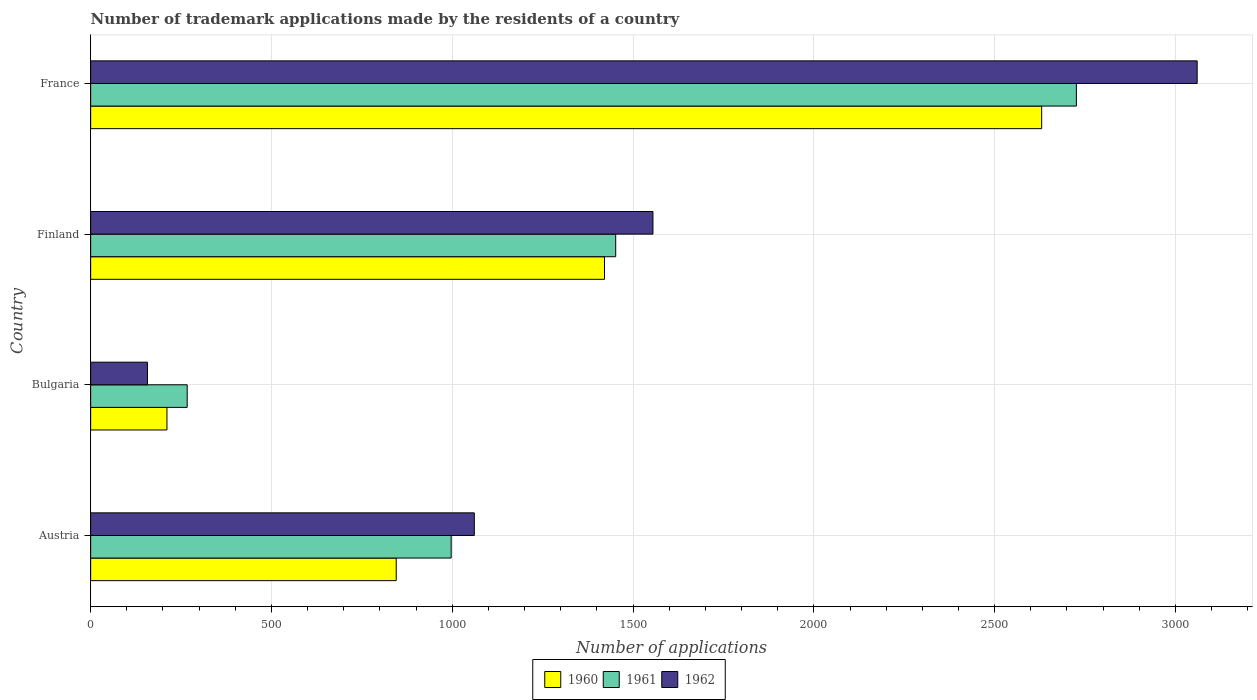How many different coloured bars are there?
Provide a short and direct response. 3. Are the number of bars per tick equal to the number of legend labels?
Your answer should be very brief. Yes. Are the number of bars on each tick of the Y-axis equal?
Give a very brief answer. Yes. How many bars are there on the 1st tick from the top?
Offer a terse response. 3. What is the label of the 4th group of bars from the top?
Your response must be concise. Austria. What is the number of trademark applications made by the residents in 1962 in Austria?
Offer a very short reply. 1061. Across all countries, what is the maximum number of trademark applications made by the residents in 1962?
Provide a short and direct response. 3060. Across all countries, what is the minimum number of trademark applications made by the residents in 1960?
Your response must be concise. 211. In which country was the number of trademark applications made by the residents in 1960 maximum?
Make the answer very short. France. In which country was the number of trademark applications made by the residents in 1960 minimum?
Offer a very short reply. Bulgaria. What is the total number of trademark applications made by the residents in 1961 in the graph?
Offer a terse response. 5442. What is the difference between the number of trademark applications made by the residents in 1960 in Finland and that in France?
Make the answer very short. -1209. What is the difference between the number of trademark applications made by the residents in 1961 in Bulgaria and the number of trademark applications made by the residents in 1962 in France?
Your answer should be very brief. -2793. What is the average number of trademark applications made by the residents in 1961 per country?
Offer a very short reply. 1360.5. What is the difference between the number of trademark applications made by the residents in 1960 and number of trademark applications made by the residents in 1961 in Bulgaria?
Make the answer very short. -56. What is the ratio of the number of trademark applications made by the residents in 1961 in Austria to that in Bulgaria?
Offer a terse response. 3.73. Is the number of trademark applications made by the residents in 1961 in Austria less than that in Bulgaria?
Offer a very short reply. No. What is the difference between the highest and the second highest number of trademark applications made by the residents in 1962?
Give a very brief answer. 1505. What is the difference between the highest and the lowest number of trademark applications made by the residents in 1960?
Your response must be concise. 2419. In how many countries, is the number of trademark applications made by the residents in 1961 greater than the average number of trademark applications made by the residents in 1961 taken over all countries?
Your answer should be compact. 2. Is it the case that in every country, the sum of the number of trademark applications made by the residents in 1962 and number of trademark applications made by the residents in 1961 is greater than the number of trademark applications made by the residents in 1960?
Offer a terse response. Yes. Are all the bars in the graph horizontal?
Provide a succinct answer. Yes. How many countries are there in the graph?
Keep it short and to the point. 4. What is the difference between two consecutive major ticks on the X-axis?
Make the answer very short. 500. Does the graph contain any zero values?
Ensure brevity in your answer.  No. How many legend labels are there?
Make the answer very short. 3. What is the title of the graph?
Give a very brief answer. Number of trademark applications made by the residents of a country. What is the label or title of the X-axis?
Your answer should be compact. Number of applications. What is the label or title of the Y-axis?
Provide a short and direct response. Country. What is the Number of applications of 1960 in Austria?
Your response must be concise. 845. What is the Number of applications of 1961 in Austria?
Give a very brief answer. 997. What is the Number of applications of 1962 in Austria?
Keep it short and to the point. 1061. What is the Number of applications of 1960 in Bulgaria?
Offer a terse response. 211. What is the Number of applications of 1961 in Bulgaria?
Your response must be concise. 267. What is the Number of applications in 1962 in Bulgaria?
Your answer should be compact. 157. What is the Number of applications of 1960 in Finland?
Offer a very short reply. 1421. What is the Number of applications in 1961 in Finland?
Provide a succinct answer. 1452. What is the Number of applications of 1962 in Finland?
Ensure brevity in your answer.  1555. What is the Number of applications in 1960 in France?
Provide a short and direct response. 2630. What is the Number of applications in 1961 in France?
Your response must be concise. 2726. What is the Number of applications in 1962 in France?
Give a very brief answer. 3060. Across all countries, what is the maximum Number of applications in 1960?
Ensure brevity in your answer.  2630. Across all countries, what is the maximum Number of applications in 1961?
Your answer should be very brief. 2726. Across all countries, what is the maximum Number of applications in 1962?
Offer a terse response. 3060. Across all countries, what is the minimum Number of applications in 1960?
Offer a very short reply. 211. Across all countries, what is the minimum Number of applications of 1961?
Your answer should be compact. 267. Across all countries, what is the minimum Number of applications in 1962?
Keep it short and to the point. 157. What is the total Number of applications of 1960 in the graph?
Provide a succinct answer. 5107. What is the total Number of applications in 1961 in the graph?
Your response must be concise. 5442. What is the total Number of applications in 1962 in the graph?
Provide a succinct answer. 5833. What is the difference between the Number of applications in 1960 in Austria and that in Bulgaria?
Offer a very short reply. 634. What is the difference between the Number of applications in 1961 in Austria and that in Bulgaria?
Offer a very short reply. 730. What is the difference between the Number of applications of 1962 in Austria and that in Bulgaria?
Give a very brief answer. 904. What is the difference between the Number of applications in 1960 in Austria and that in Finland?
Provide a short and direct response. -576. What is the difference between the Number of applications in 1961 in Austria and that in Finland?
Your answer should be compact. -455. What is the difference between the Number of applications in 1962 in Austria and that in Finland?
Give a very brief answer. -494. What is the difference between the Number of applications of 1960 in Austria and that in France?
Provide a succinct answer. -1785. What is the difference between the Number of applications in 1961 in Austria and that in France?
Your answer should be very brief. -1729. What is the difference between the Number of applications in 1962 in Austria and that in France?
Your response must be concise. -1999. What is the difference between the Number of applications in 1960 in Bulgaria and that in Finland?
Make the answer very short. -1210. What is the difference between the Number of applications in 1961 in Bulgaria and that in Finland?
Your answer should be very brief. -1185. What is the difference between the Number of applications of 1962 in Bulgaria and that in Finland?
Keep it short and to the point. -1398. What is the difference between the Number of applications of 1960 in Bulgaria and that in France?
Your answer should be compact. -2419. What is the difference between the Number of applications in 1961 in Bulgaria and that in France?
Provide a short and direct response. -2459. What is the difference between the Number of applications in 1962 in Bulgaria and that in France?
Make the answer very short. -2903. What is the difference between the Number of applications in 1960 in Finland and that in France?
Your answer should be very brief. -1209. What is the difference between the Number of applications of 1961 in Finland and that in France?
Your answer should be very brief. -1274. What is the difference between the Number of applications of 1962 in Finland and that in France?
Provide a short and direct response. -1505. What is the difference between the Number of applications of 1960 in Austria and the Number of applications of 1961 in Bulgaria?
Your answer should be very brief. 578. What is the difference between the Number of applications in 1960 in Austria and the Number of applications in 1962 in Bulgaria?
Provide a short and direct response. 688. What is the difference between the Number of applications of 1961 in Austria and the Number of applications of 1962 in Bulgaria?
Your answer should be very brief. 840. What is the difference between the Number of applications of 1960 in Austria and the Number of applications of 1961 in Finland?
Offer a very short reply. -607. What is the difference between the Number of applications of 1960 in Austria and the Number of applications of 1962 in Finland?
Your response must be concise. -710. What is the difference between the Number of applications of 1961 in Austria and the Number of applications of 1962 in Finland?
Your answer should be very brief. -558. What is the difference between the Number of applications in 1960 in Austria and the Number of applications in 1961 in France?
Provide a succinct answer. -1881. What is the difference between the Number of applications in 1960 in Austria and the Number of applications in 1962 in France?
Provide a short and direct response. -2215. What is the difference between the Number of applications in 1961 in Austria and the Number of applications in 1962 in France?
Offer a very short reply. -2063. What is the difference between the Number of applications of 1960 in Bulgaria and the Number of applications of 1961 in Finland?
Ensure brevity in your answer.  -1241. What is the difference between the Number of applications in 1960 in Bulgaria and the Number of applications in 1962 in Finland?
Offer a very short reply. -1344. What is the difference between the Number of applications in 1961 in Bulgaria and the Number of applications in 1962 in Finland?
Provide a succinct answer. -1288. What is the difference between the Number of applications in 1960 in Bulgaria and the Number of applications in 1961 in France?
Offer a very short reply. -2515. What is the difference between the Number of applications of 1960 in Bulgaria and the Number of applications of 1962 in France?
Give a very brief answer. -2849. What is the difference between the Number of applications in 1961 in Bulgaria and the Number of applications in 1962 in France?
Keep it short and to the point. -2793. What is the difference between the Number of applications of 1960 in Finland and the Number of applications of 1961 in France?
Offer a terse response. -1305. What is the difference between the Number of applications of 1960 in Finland and the Number of applications of 1962 in France?
Your answer should be very brief. -1639. What is the difference between the Number of applications in 1961 in Finland and the Number of applications in 1962 in France?
Your answer should be very brief. -1608. What is the average Number of applications of 1960 per country?
Provide a succinct answer. 1276.75. What is the average Number of applications in 1961 per country?
Give a very brief answer. 1360.5. What is the average Number of applications in 1962 per country?
Keep it short and to the point. 1458.25. What is the difference between the Number of applications in 1960 and Number of applications in 1961 in Austria?
Provide a short and direct response. -152. What is the difference between the Number of applications in 1960 and Number of applications in 1962 in Austria?
Make the answer very short. -216. What is the difference between the Number of applications in 1961 and Number of applications in 1962 in Austria?
Ensure brevity in your answer.  -64. What is the difference between the Number of applications of 1960 and Number of applications of 1961 in Bulgaria?
Ensure brevity in your answer.  -56. What is the difference between the Number of applications of 1961 and Number of applications of 1962 in Bulgaria?
Make the answer very short. 110. What is the difference between the Number of applications of 1960 and Number of applications of 1961 in Finland?
Give a very brief answer. -31. What is the difference between the Number of applications in 1960 and Number of applications in 1962 in Finland?
Make the answer very short. -134. What is the difference between the Number of applications of 1961 and Number of applications of 1962 in Finland?
Your answer should be compact. -103. What is the difference between the Number of applications of 1960 and Number of applications of 1961 in France?
Offer a very short reply. -96. What is the difference between the Number of applications of 1960 and Number of applications of 1962 in France?
Your answer should be compact. -430. What is the difference between the Number of applications in 1961 and Number of applications in 1962 in France?
Your answer should be very brief. -334. What is the ratio of the Number of applications of 1960 in Austria to that in Bulgaria?
Your answer should be compact. 4. What is the ratio of the Number of applications in 1961 in Austria to that in Bulgaria?
Provide a succinct answer. 3.73. What is the ratio of the Number of applications in 1962 in Austria to that in Bulgaria?
Your answer should be compact. 6.76. What is the ratio of the Number of applications of 1960 in Austria to that in Finland?
Offer a terse response. 0.59. What is the ratio of the Number of applications of 1961 in Austria to that in Finland?
Make the answer very short. 0.69. What is the ratio of the Number of applications in 1962 in Austria to that in Finland?
Give a very brief answer. 0.68. What is the ratio of the Number of applications of 1960 in Austria to that in France?
Provide a succinct answer. 0.32. What is the ratio of the Number of applications in 1961 in Austria to that in France?
Make the answer very short. 0.37. What is the ratio of the Number of applications of 1962 in Austria to that in France?
Your answer should be very brief. 0.35. What is the ratio of the Number of applications of 1960 in Bulgaria to that in Finland?
Offer a terse response. 0.15. What is the ratio of the Number of applications in 1961 in Bulgaria to that in Finland?
Keep it short and to the point. 0.18. What is the ratio of the Number of applications of 1962 in Bulgaria to that in Finland?
Offer a very short reply. 0.1. What is the ratio of the Number of applications in 1960 in Bulgaria to that in France?
Offer a terse response. 0.08. What is the ratio of the Number of applications in 1961 in Bulgaria to that in France?
Provide a succinct answer. 0.1. What is the ratio of the Number of applications of 1962 in Bulgaria to that in France?
Give a very brief answer. 0.05. What is the ratio of the Number of applications in 1960 in Finland to that in France?
Offer a very short reply. 0.54. What is the ratio of the Number of applications in 1961 in Finland to that in France?
Provide a succinct answer. 0.53. What is the ratio of the Number of applications of 1962 in Finland to that in France?
Provide a succinct answer. 0.51. What is the difference between the highest and the second highest Number of applications in 1960?
Give a very brief answer. 1209. What is the difference between the highest and the second highest Number of applications of 1961?
Your answer should be compact. 1274. What is the difference between the highest and the second highest Number of applications of 1962?
Offer a very short reply. 1505. What is the difference between the highest and the lowest Number of applications in 1960?
Your answer should be very brief. 2419. What is the difference between the highest and the lowest Number of applications of 1961?
Offer a very short reply. 2459. What is the difference between the highest and the lowest Number of applications in 1962?
Your response must be concise. 2903. 